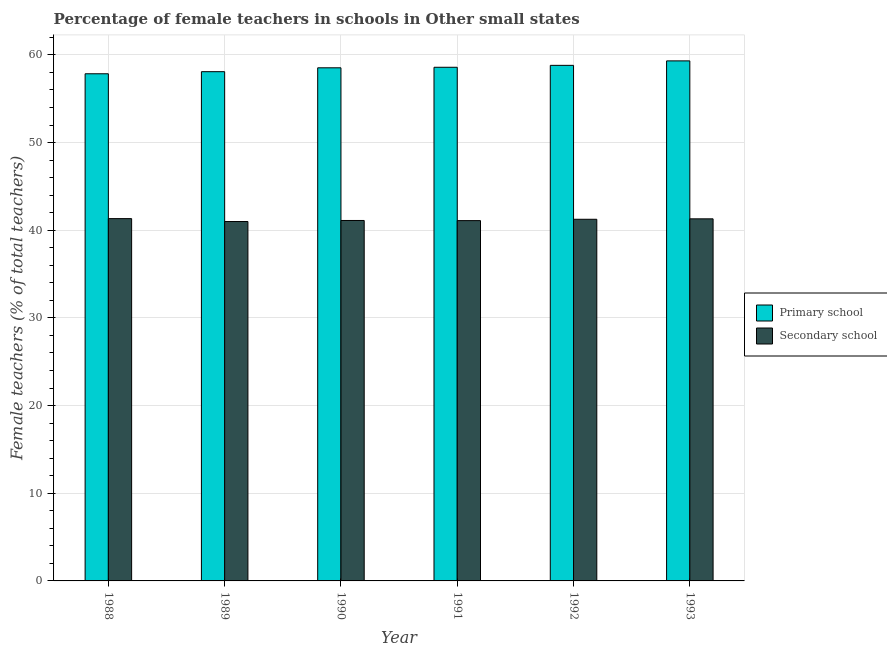How many bars are there on the 5th tick from the left?
Provide a short and direct response. 2. How many bars are there on the 1st tick from the right?
Ensure brevity in your answer.  2. What is the percentage of female teachers in primary schools in 1991?
Make the answer very short. 58.59. Across all years, what is the maximum percentage of female teachers in secondary schools?
Keep it short and to the point. 41.33. Across all years, what is the minimum percentage of female teachers in primary schools?
Your answer should be very brief. 57.85. In which year was the percentage of female teachers in primary schools maximum?
Your answer should be very brief. 1993. In which year was the percentage of female teachers in primary schools minimum?
Your answer should be compact. 1988. What is the total percentage of female teachers in primary schools in the graph?
Make the answer very short. 351.18. What is the difference between the percentage of female teachers in secondary schools in 1992 and that in 1993?
Your answer should be very brief. -0.05. What is the difference between the percentage of female teachers in primary schools in 1990 and the percentage of female teachers in secondary schools in 1988?
Provide a succinct answer. 0.68. What is the average percentage of female teachers in primary schools per year?
Your response must be concise. 58.53. What is the ratio of the percentage of female teachers in primary schools in 1988 to that in 1990?
Give a very brief answer. 0.99. What is the difference between the highest and the second highest percentage of female teachers in primary schools?
Provide a succinct answer. 0.51. What is the difference between the highest and the lowest percentage of female teachers in primary schools?
Make the answer very short. 1.47. What does the 1st bar from the left in 1991 represents?
Ensure brevity in your answer.  Primary school. What does the 2nd bar from the right in 1989 represents?
Provide a succinct answer. Primary school. Are all the bars in the graph horizontal?
Offer a terse response. No. How many years are there in the graph?
Offer a terse response. 6. What is the difference between two consecutive major ticks on the Y-axis?
Provide a succinct answer. 10. Are the values on the major ticks of Y-axis written in scientific E-notation?
Your answer should be very brief. No. Where does the legend appear in the graph?
Your answer should be compact. Center right. How are the legend labels stacked?
Your answer should be compact. Vertical. What is the title of the graph?
Offer a very short reply. Percentage of female teachers in schools in Other small states. What is the label or title of the X-axis?
Provide a short and direct response. Year. What is the label or title of the Y-axis?
Make the answer very short. Female teachers (% of total teachers). What is the Female teachers (% of total teachers) in Primary school in 1988?
Your answer should be very brief. 57.85. What is the Female teachers (% of total teachers) of Secondary school in 1988?
Keep it short and to the point. 41.33. What is the Female teachers (% of total teachers) of Primary school in 1989?
Ensure brevity in your answer.  58.09. What is the Female teachers (% of total teachers) in Secondary school in 1989?
Provide a succinct answer. 41. What is the Female teachers (% of total teachers) of Primary school in 1990?
Give a very brief answer. 58.53. What is the Female teachers (% of total teachers) in Secondary school in 1990?
Your answer should be very brief. 41.11. What is the Female teachers (% of total teachers) in Primary school in 1991?
Give a very brief answer. 58.59. What is the Female teachers (% of total teachers) of Secondary school in 1991?
Offer a very short reply. 41.1. What is the Female teachers (% of total teachers) of Primary school in 1992?
Offer a very short reply. 58.81. What is the Female teachers (% of total teachers) in Secondary school in 1992?
Ensure brevity in your answer.  41.25. What is the Female teachers (% of total teachers) in Primary school in 1993?
Provide a short and direct response. 59.32. What is the Female teachers (% of total teachers) in Secondary school in 1993?
Give a very brief answer. 41.3. Across all years, what is the maximum Female teachers (% of total teachers) in Primary school?
Offer a very short reply. 59.32. Across all years, what is the maximum Female teachers (% of total teachers) in Secondary school?
Provide a short and direct response. 41.33. Across all years, what is the minimum Female teachers (% of total teachers) of Primary school?
Give a very brief answer. 57.85. Across all years, what is the minimum Female teachers (% of total teachers) of Secondary school?
Your response must be concise. 41. What is the total Female teachers (% of total teachers) of Primary school in the graph?
Make the answer very short. 351.18. What is the total Female teachers (% of total teachers) in Secondary school in the graph?
Give a very brief answer. 247.09. What is the difference between the Female teachers (% of total teachers) in Primary school in 1988 and that in 1989?
Your answer should be very brief. -0.24. What is the difference between the Female teachers (% of total teachers) of Secondary school in 1988 and that in 1989?
Give a very brief answer. 0.33. What is the difference between the Female teachers (% of total teachers) of Primary school in 1988 and that in 1990?
Your answer should be very brief. -0.68. What is the difference between the Female teachers (% of total teachers) of Secondary school in 1988 and that in 1990?
Provide a succinct answer. 0.21. What is the difference between the Female teachers (% of total teachers) in Primary school in 1988 and that in 1991?
Offer a terse response. -0.74. What is the difference between the Female teachers (% of total teachers) of Secondary school in 1988 and that in 1991?
Make the answer very short. 0.23. What is the difference between the Female teachers (% of total teachers) in Primary school in 1988 and that in 1992?
Offer a very short reply. -0.96. What is the difference between the Female teachers (% of total teachers) of Secondary school in 1988 and that in 1992?
Offer a very short reply. 0.07. What is the difference between the Female teachers (% of total teachers) of Primary school in 1988 and that in 1993?
Provide a succinct answer. -1.47. What is the difference between the Female teachers (% of total teachers) of Secondary school in 1988 and that in 1993?
Keep it short and to the point. 0.02. What is the difference between the Female teachers (% of total teachers) of Primary school in 1989 and that in 1990?
Your answer should be compact. -0.44. What is the difference between the Female teachers (% of total teachers) of Secondary school in 1989 and that in 1990?
Ensure brevity in your answer.  -0.12. What is the difference between the Female teachers (% of total teachers) in Primary school in 1989 and that in 1991?
Your answer should be compact. -0.5. What is the difference between the Female teachers (% of total teachers) of Secondary school in 1989 and that in 1991?
Keep it short and to the point. -0.1. What is the difference between the Female teachers (% of total teachers) of Primary school in 1989 and that in 1992?
Offer a terse response. -0.72. What is the difference between the Female teachers (% of total teachers) of Secondary school in 1989 and that in 1992?
Provide a short and direct response. -0.26. What is the difference between the Female teachers (% of total teachers) in Primary school in 1989 and that in 1993?
Your response must be concise. -1.23. What is the difference between the Female teachers (% of total teachers) of Secondary school in 1989 and that in 1993?
Provide a succinct answer. -0.31. What is the difference between the Female teachers (% of total teachers) of Primary school in 1990 and that in 1991?
Ensure brevity in your answer.  -0.06. What is the difference between the Female teachers (% of total teachers) in Secondary school in 1990 and that in 1991?
Make the answer very short. 0.02. What is the difference between the Female teachers (% of total teachers) in Primary school in 1990 and that in 1992?
Ensure brevity in your answer.  -0.28. What is the difference between the Female teachers (% of total teachers) of Secondary school in 1990 and that in 1992?
Provide a short and direct response. -0.14. What is the difference between the Female teachers (% of total teachers) in Primary school in 1990 and that in 1993?
Offer a terse response. -0.79. What is the difference between the Female teachers (% of total teachers) of Secondary school in 1990 and that in 1993?
Offer a very short reply. -0.19. What is the difference between the Female teachers (% of total teachers) of Primary school in 1991 and that in 1992?
Provide a short and direct response. -0.22. What is the difference between the Female teachers (% of total teachers) in Secondary school in 1991 and that in 1992?
Provide a short and direct response. -0.15. What is the difference between the Female teachers (% of total teachers) of Primary school in 1991 and that in 1993?
Your answer should be very brief. -0.73. What is the difference between the Female teachers (% of total teachers) in Secondary school in 1991 and that in 1993?
Offer a very short reply. -0.2. What is the difference between the Female teachers (% of total teachers) of Primary school in 1992 and that in 1993?
Provide a succinct answer. -0.51. What is the difference between the Female teachers (% of total teachers) of Secondary school in 1992 and that in 1993?
Offer a terse response. -0.05. What is the difference between the Female teachers (% of total teachers) of Primary school in 1988 and the Female teachers (% of total teachers) of Secondary school in 1989?
Offer a very short reply. 16.85. What is the difference between the Female teachers (% of total teachers) of Primary school in 1988 and the Female teachers (% of total teachers) of Secondary school in 1990?
Offer a very short reply. 16.73. What is the difference between the Female teachers (% of total teachers) in Primary school in 1988 and the Female teachers (% of total teachers) in Secondary school in 1991?
Provide a succinct answer. 16.75. What is the difference between the Female teachers (% of total teachers) of Primary school in 1988 and the Female teachers (% of total teachers) of Secondary school in 1992?
Your response must be concise. 16.6. What is the difference between the Female teachers (% of total teachers) in Primary school in 1988 and the Female teachers (% of total teachers) in Secondary school in 1993?
Your response must be concise. 16.55. What is the difference between the Female teachers (% of total teachers) of Primary school in 1989 and the Female teachers (% of total teachers) of Secondary school in 1990?
Offer a terse response. 16.97. What is the difference between the Female teachers (% of total teachers) of Primary school in 1989 and the Female teachers (% of total teachers) of Secondary school in 1991?
Make the answer very short. 16.99. What is the difference between the Female teachers (% of total teachers) of Primary school in 1989 and the Female teachers (% of total teachers) of Secondary school in 1992?
Your answer should be compact. 16.84. What is the difference between the Female teachers (% of total teachers) in Primary school in 1989 and the Female teachers (% of total teachers) in Secondary school in 1993?
Give a very brief answer. 16.79. What is the difference between the Female teachers (% of total teachers) of Primary school in 1990 and the Female teachers (% of total teachers) of Secondary school in 1991?
Provide a succinct answer. 17.43. What is the difference between the Female teachers (% of total teachers) in Primary school in 1990 and the Female teachers (% of total teachers) in Secondary school in 1992?
Offer a very short reply. 17.28. What is the difference between the Female teachers (% of total teachers) in Primary school in 1990 and the Female teachers (% of total teachers) in Secondary school in 1993?
Your response must be concise. 17.23. What is the difference between the Female teachers (% of total teachers) of Primary school in 1991 and the Female teachers (% of total teachers) of Secondary school in 1992?
Offer a very short reply. 17.34. What is the difference between the Female teachers (% of total teachers) of Primary school in 1991 and the Female teachers (% of total teachers) of Secondary school in 1993?
Your response must be concise. 17.29. What is the difference between the Female teachers (% of total teachers) of Primary school in 1992 and the Female teachers (% of total teachers) of Secondary school in 1993?
Ensure brevity in your answer.  17.51. What is the average Female teachers (% of total teachers) in Primary school per year?
Your answer should be compact. 58.53. What is the average Female teachers (% of total teachers) in Secondary school per year?
Provide a short and direct response. 41.18. In the year 1988, what is the difference between the Female teachers (% of total teachers) of Primary school and Female teachers (% of total teachers) of Secondary school?
Give a very brief answer. 16.52. In the year 1989, what is the difference between the Female teachers (% of total teachers) in Primary school and Female teachers (% of total teachers) in Secondary school?
Give a very brief answer. 17.09. In the year 1990, what is the difference between the Female teachers (% of total teachers) of Primary school and Female teachers (% of total teachers) of Secondary school?
Your response must be concise. 17.41. In the year 1991, what is the difference between the Female teachers (% of total teachers) of Primary school and Female teachers (% of total teachers) of Secondary school?
Your response must be concise. 17.49. In the year 1992, what is the difference between the Female teachers (% of total teachers) of Primary school and Female teachers (% of total teachers) of Secondary school?
Provide a short and direct response. 17.56. In the year 1993, what is the difference between the Female teachers (% of total teachers) in Primary school and Female teachers (% of total teachers) in Secondary school?
Your answer should be compact. 18.02. What is the ratio of the Female teachers (% of total teachers) of Primary school in 1988 to that in 1989?
Your answer should be compact. 1. What is the ratio of the Female teachers (% of total teachers) in Secondary school in 1988 to that in 1989?
Offer a terse response. 1.01. What is the ratio of the Female teachers (% of total teachers) in Primary school in 1988 to that in 1990?
Give a very brief answer. 0.99. What is the ratio of the Female teachers (% of total teachers) of Primary school in 1988 to that in 1991?
Your response must be concise. 0.99. What is the ratio of the Female teachers (% of total teachers) in Primary school in 1988 to that in 1992?
Make the answer very short. 0.98. What is the ratio of the Female teachers (% of total teachers) in Primary school in 1988 to that in 1993?
Ensure brevity in your answer.  0.98. What is the ratio of the Female teachers (% of total teachers) in Secondary school in 1989 to that in 1990?
Provide a short and direct response. 1. What is the ratio of the Female teachers (% of total teachers) in Secondary school in 1989 to that in 1991?
Make the answer very short. 1. What is the ratio of the Female teachers (% of total teachers) of Primary school in 1989 to that in 1992?
Ensure brevity in your answer.  0.99. What is the ratio of the Female teachers (% of total teachers) in Secondary school in 1989 to that in 1992?
Your answer should be compact. 0.99. What is the ratio of the Female teachers (% of total teachers) in Primary school in 1989 to that in 1993?
Keep it short and to the point. 0.98. What is the ratio of the Female teachers (% of total teachers) in Secondary school in 1989 to that in 1993?
Make the answer very short. 0.99. What is the ratio of the Female teachers (% of total teachers) of Primary school in 1990 to that in 1991?
Make the answer very short. 1. What is the ratio of the Female teachers (% of total teachers) of Secondary school in 1990 to that in 1991?
Your answer should be compact. 1. What is the ratio of the Female teachers (% of total teachers) of Secondary school in 1990 to that in 1992?
Give a very brief answer. 1. What is the ratio of the Female teachers (% of total teachers) of Primary school in 1990 to that in 1993?
Offer a very short reply. 0.99. What is the ratio of the Female teachers (% of total teachers) of Secondary school in 1990 to that in 1993?
Give a very brief answer. 1. What is the ratio of the Female teachers (% of total teachers) of Primary school in 1991 to that in 1993?
Your answer should be compact. 0.99. What is the difference between the highest and the second highest Female teachers (% of total teachers) in Primary school?
Provide a short and direct response. 0.51. What is the difference between the highest and the second highest Female teachers (% of total teachers) of Secondary school?
Provide a succinct answer. 0.02. What is the difference between the highest and the lowest Female teachers (% of total teachers) of Primary school?
Provide a short and direct response. 1.47. What is the difference between the highest and the lowest Female teachers (% of total teachers) of Secondary school?
Offer a very short reply. 0.33. 